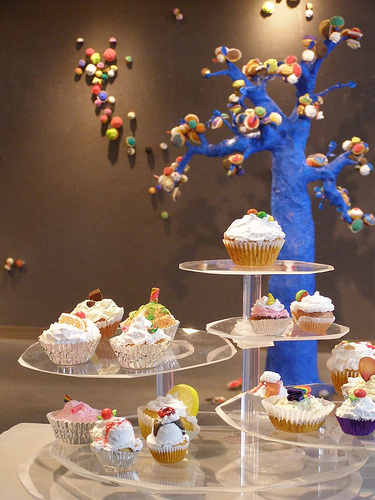<image>
Is there a cupcake on the table? Yes. Looking at the image, I can see the cupcake is positioned on top of the table, with the table providing support. Where is the puffs in relation to the cupcakes? Is it in front of the cupcakes? No. The puffs is not in front of the cupcakes. The spatial positioning shows a different relationship between these objects. 